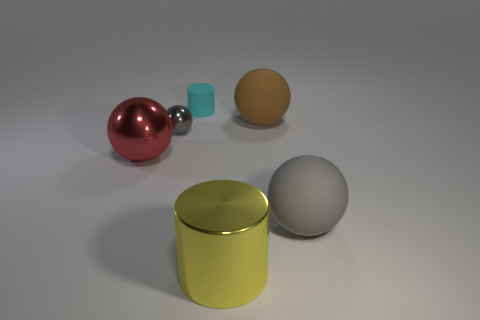Add 2 big yellow balls. How many objects exist? 8 Subtract all cylinders. How many objects are left? 4 Subtract 0 purple cylinders. How many objects are left? 6 Subtract all big brown spheres. Subtract all gray metallic objects. How many objects are left? 4 Add 2 gray rubber objects. How many gray rubber objects are left? 3 Add 2 large red metallic spheres. How many large red metallic spheres exist? 3 